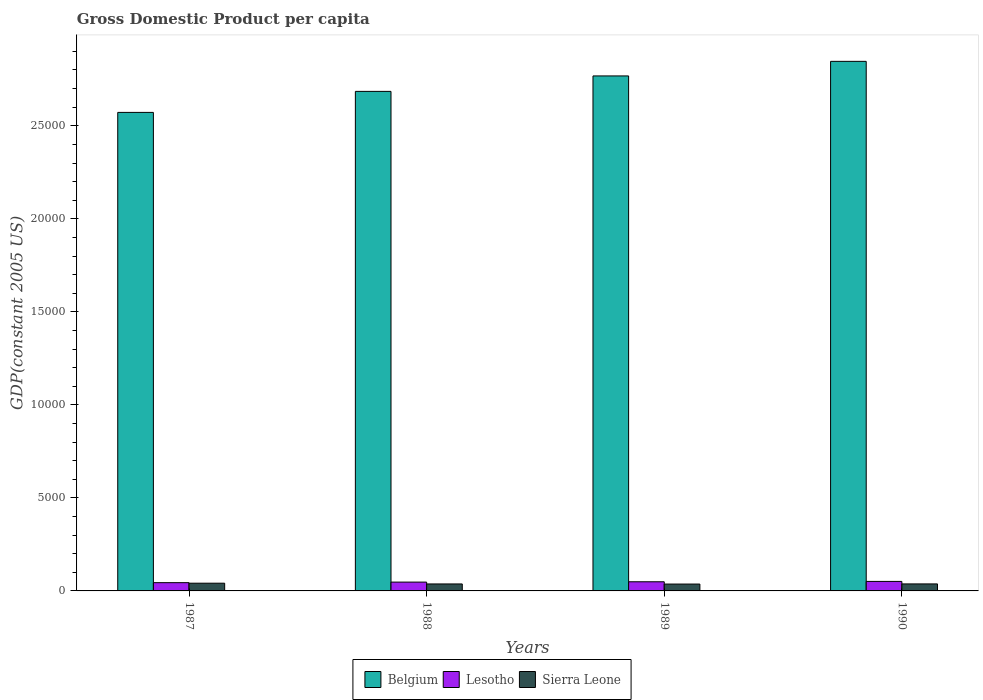How many groups of bars are there?
Offer a very short reply. 4. Are the number of bars per tick equal to the number of legend labels?
Your response must be concise. Yes. How many bars are there on the 3rd tick from the right?
Keep it short and to the point. 3. What is the GDP per capita in Belgium in 1989?
Ensure brevity in your answer.  2.77e+04. Across all years, what is the maximum GDP per capita in Sierra Leone?
Provide a succinct answer. 415.48. Across all years, what is the minimum GDP per capita in Belgium?
Offer a terse response. 2.57e+04. In which year was the GDP per capita in Lesotho maximum?
Keep it short and to the point. 1990. What is the total GDP per capita in Belgium in the graph?
Give a very brief answer. 1.09e+05. What is the difference between the GDP per capita in Lesotho in 1988 and that in 1989?
Your response must be concise. -17.88. What is the difference between the GDP per capita in Sierra Leone in 1989 and the GDP per capita in Belgium in 1990?
Keep it short and to the point. -2.81e+04. What is the average GDP per capita in Sierra Leone per year?
Keep it short and to the point. 384.01. In the year 1990, what is the difference between the GDP per capita in Sierra Leone and GDP per capita in Lesotho?
Keep it short and to the point. -134.24. In how many years, is the GDP per capita in Belgium greater than 4000 US$?
Provide a succinct answer. 4. What is the ratio of the GDP per capita in Lesotho in 1988 to that in 1989?
Provide a short and direct response. 0.96. Is the difference between the GDP per capita in Sierra Leone in 1987 and 1989 greater than the difference between the GDP per capita in Lesotho in 1987 and 1989?
Provide a short and direct response. Yes. What is the difference between the highest and the second highest GDP per capita in Sierra Leone?
Keep it short and to the point. 39.05. What is the difference between the highest and the lowest GDP per capita in Sierra Leone?
Your answer should be compact. 46.28. In how many years, is the GDP per capita in Lesotho greater than the average GDP per capita in Lesotho taken over all years?
Your answer should be very brief. 2. Is the sum of the GDP per capita in Belgium in 1988 and 1990 greater than the maximum GDP per capita in Lesotho across all years?
Ensure brevity in your answer.  Yes. What does the 3rd bar from the left in 1988 represents?
Your answer should be compact. Sierra Leone. What does the 1st bar from the right in 1989 represents?
Your response must be concise. Sierra Leone. Is it the case that in every year, the sum of the GDP per capita in Sierra Leone and GDP per capita in Lesotho is greater than the GDP per capita in Belgium?
Provide a succinct answer. No. Are all the bars in the graph horizontal?
Provide a succinct answer. No. Where does the legend appear in the graph?
Ensure brevity in your answer.  Bottom center. How many legend labels are there?
Offer a terse response. 3. How are the legend labels stacked?
Keep it short and to the point. Horizontal. What is the title of the graph?
Your answer should be compact. Gross Domestic Product per capita. Does "New Caledonia" appear as one of the legend labels in the graph?
Ensure brevity in your answer.  No. What is the label or title of the X-axis?
Your response must be concise. Years. What is the label or title of the Y-axis?
Your response must be concise. GDP(constant 2005 US). What is the GDP(constant 2005 US) of Belgium in 1987?
Keep it short and to the point. 2.57e+04. What is the GDP(constant 2005 US) of Lesotho in 1987?
Offer a terse response. 443.63. What is the GDP(constant 2005 US) of Sierra Leone in 1987?
Give a very brief answer. 415.48. What is the GDP(constant 2005 US) of Belgium in 1988?
Make the answer very short. 2.69e+04. What is the GDP(constant 2005 US) of Lesotho in 1988?
Your answer should be compact. 474. What is the GDP(constant 2005 US) of Sierra Leone in 1988?
Ensure brevity in your answer.  374.95. What is the GDP(constant 2005 US) of Belgium in 1989?
Your answer should be very brief. 2.77e+04. What is the GDP(constant 2005 US) of Lesotho in 1989?
Offer a terse response. 491.88. What is the GDP(constant 2005 US) of Sierra Leone in 1989?
Give a very brief answer. 369.2. What is the GDP(constant 2005 US) in Belgium in 1990?
Make the answer very short. 2.85e+04. What is the GDP(constant 2005 US) of Lesotho in 1990?
Offer a terse response. 510.67. What is the GDP(constant 2005 US) in Sierra Leone in 1990?
Provide a short and direct response. 376.42. Across all years, what is the maximum GDP(constant 2005 US) of Belgium?
Give a very brief answer. 2.85e+04. Across all years, what is the maximum GDP(constant 2005 US) in Lesotho?
Give a very brief answer. 510.67. Across all years, what is the maximum GDP(constant 2005 US) in Sierra Leone?
Keep it short and to the point. 415.48. Across all years, what is the minimum GDP(constant 2005 US) of Belgium?
Provide a short and direct response. 2.57e+04. Across all years, what is the minimum GDP(constant 2005 US) of Lesotho?
Ensure brevity in your answer.  443.63. Across all years, what is the minimum GDP(constant 2005 US) in Sierra Leone?
Your answer should be compact. 369.2. What is the total GDP(constant 2005 US) of Belgium in the graph?
Your answer should be very brief. 1.09e+05. What is the total GDP(constant 2005 US) in Lesotho in the graph?
Your answer should be compact. 1920.18. What is the total GDP(constant 2005 US) of Sierra Leone in the graph?
Your answer should be compact. 1536.05. What is the difference between the GDP(constant 2005 US) of Belgium in 1987 and that in 1988?
Ensure brevity in your answer.  -1129.35. What is the difference between the GDP(constant 2005 US) of Lesotho in 1987 and that in 1988?
Ensure brevity in your answer.  -30.37. What is the difference between the GDP(constant 2005 US) in Sierra Leone in 1987 and that in 1988?
Ensure brevity in your answer.  40.53. What is the difference between the GDP(constant 2005 US) in Belgium in 1987 and that in 1989?
Ensure brevity in your answer.  -1960.1. What is the difference between the GDP(constant 2005 US) in Lesotho in 1987 and that in 1989?
Your answer should be compact. -48.26. What is the difference between the GDP(constant 2005 US) of Sierra Leone in 1987 and that in 1989?
Offer a terse response. 46.28. What is the difference between the GDP(constant 2005 US) of Belgium in 1987 and that in 1990?
Your response must be concise. -2743.54. What is the difference between the GDP(constant 2005 US) of Lesotho in 1987 and that in 1990?
Offer a terse response. -67.04. What is the difference between the GDP(constant 2005 US) of Sierra Leone in 1987 and that in 1990?
Your response must be concise. 39.05. What is the difference between the GDP(constant 2005 US) in Belgium in 1988 and that in 1989?
Your answer should be very brief. -830.75. What is the difference between the GDP(constant 2005 US) in Lesotho in 1988 and that in 1989?
Offer a terse response. -17.88. What is the difference between the GDP(constant 2005 US) in Sierra Leone in 1988 and that in 1989?
Your answer should be very brief. 5.75. What is the difference between the GDP(constant 2005 US) in Belgium in 1988 and that in 1990?
Keep it short and to the point. -1614.19. What is the difference between the GDP(constant 2005 US) of Lesotho in 1988 and that in 1990?
Make the answer very short. -36.67. What is the difference between the GDP(constant 2005 US) of Sierra Leone in 1988 and that in 1990?
Make the answer very short. -1.48. What is the difference between the GDP(constant 2005 US) of Belgium in 1989 and that in 1990?
Offer a terse response. -783.45. What is the difference between the GDP(constant 2005 US) in Lesotho in 1989 and that in 1990?
Keep it short and to the point. -18.79. What is the difference between the GDP(constant 2005 US) in Sierra Leone in 1989 and that in 1990?
Offer a terse response. -7.22. What is the difference between the GDP(constant 2005 US) in Belgium in 1987 and the GDP(constant 2005 US) in Lesotho in 1988?
Keep it short and to the point. 2.52e+04. What is the difference between the GDP(constant 2005 US) in Belgium in 1987 and the GDP(constant 2005 US) in Sierra Leone in 1988?
Offer a very short reply. 2.53e+04. What is the difference between the GDP(constant 2005 US) of Lesotho in 1987 and the GDP(constant 2005 US) of Sierra Leone in 1988?
Give a very brief answer. 68.68. What is the difference between the GDP(constant 2005 US) of Belgium in 1987 and the GDP(constant 2005 US) of Lesotho in 1989?
Offer a terse response. 2.52e+04. What is the difference between the GDP(constant 2005 US) in Belgium in 1987 and the GDP(constant 2005 US) in Sierra Leone in 1989?
Make the answer very short. 2.54e+04. What is the difference between the GDP(constant 2005 US) in Lesotho in 1987 and the GDP(constant 2005 US) in Sierra Leone in 1989?
Offer a terse response. 74.43. What is the difference between the GDP(constant 2005 US) in Belgium in 1987 and the GDP(constant 2005 US) in Lesotho in 1990?
Make the answer very short. 2.52e+04. What is the difference between the GDP(constant 2005 US) in Belgium in 1987 and the GDP(constant 2005 US) in Sierra Leone in 1990?
Offer a terse response. 2.53e+04. What is the difference between the GDP(constant 2005 US) of Lesotho in 1987 and the GDP(constant 2005 US) of Sierra Leone in 1990?
Make the answer very short. 67.2. What is the difference between the GDP(constant 2005 US) of Belgium in 1988 and the GDP(constant 2005 US) of Lesotho in 1989?
Your answer should be compact. 2.64e+04. What is the difference between the GDP(constant 2005 US) in Belgium in 1988 and the GDP(constant 2005 US) in Sierra Leone in 1989?
Offer a terse response. 2.65e+04. What is the difference between the GDP(constant 2005 US) in Lesotho in 1988 and the GDP(constant 2005 US) in Sierra Leone in 1989?
Ensure brevity in your answer.  104.8. What is the difference between the GDP(constant 2005 US) of Belgium in 1988 and the GDP(constant 2005 US) of Lesotho in 1990?
Your answer should be very brief. 2.63e+04. What is the difference between the GDP(constant 2005 US) of Belgium in 1988 and the GDP(constant 2005 US) of Sierra Leone in 1990?
Provide a succinct answer. 2.65e+04. What is the difference between the GDP(constant 2005 US) in Lesotho in 1988 and the GDP(constant 2005 US) in Sierra Leone in 1990?
Offer a terse response. 97.57. What is the difference between the GDP(constant 2005 US) in Belgium in 1989 and the GDP(constant 2005 US) in Lesotho in 1990?
Your answer should be compact. 2.72e+04. What is the difference between the GDP(constant 2005 US) of Belgium in 1989 and the GDP(constant 2005 US) of Sierra Leone in 1990?
Your response must be concise. 2.73e+04. What is the difference between the GDP(constant 2005 US) in Lesotho in 1989 and the GDP(constant 2005 US) in Sierra Leone in 1990?
Your answer should be compact. 115.46. What is the average GDP(constant 2005 US) of Belgium per year?
Provide a succinct answer. 2.72e+04. What is the average GDP(constant 2005 US) of Lesotho per year?
Offer a terse response. 480.04. What is the average GDP(constant 2005 US) in Sierra Leone per year?
Your response must be concise. 384.01. In the year 1987, what is the difference between the GDP(constant 2005 US) in Belgium and GDP(constant 2005 US) in Lesotho?
Your answer should be compact. 2.53e+04. In the year 1987, what is the difference between the GDP(constant 2005 US) in Belgium and GDP(constant 2005 US) in Sierra Leone?
Your response must be concise. 2.53e+04. In the year 1987, what is the difference between the GDP(constant 2005 US) of Lesotho and GDP(constant 2005 US) of Sierra Leone?
Your response must be concise. 28.15. In the year 1988, what is the difference between the GDP(constant 2005 US) of Belgium and GDP(constant 2005 US) of Lesotho?
Offer a very short reply. 2.64e+04. In the year 1988, what is the difference between the GDP(constant 2005 US) of Belgium and GDP(constant 2005 US) of Sierra Leone?
Provide a short and direct response. 2.65e+04. In the year 1988, what is the difference between the GDP(constant 2005 US) of Lesotho and GDP(constant 2005 US) of Sierra Leone?
Make the answer very short. 99.05. In the year 1989, what is the difference between the GDP(constant 2005 US) of Belgium and GDP(constant 2005 US) of Lesotho?
Ensure brevity in your answer.  2.72e+04. In the year 1989, what is the difference between the GDP(constant 2005 US) of Belgium and GDP(constant 2005 US) of Sierra Leone?
Make the answer very short. 2.73e+04. In the year 1989, what is the difference between the GDP(constant 2005 US) in Lesotho and GDP(constant 2005 US) in Sierra Leone?
Ensure brevity in your answer.  122.68. In the year 1990, what is the difference between the GDP(constant 2005 US) in Belgium and GDP(constant 2005 US) in Lesotho?
Keep it short and to the point. 2.80e+04. In the year 1990, what is the difference between the GDP(constant 2005 US) in Belgium and GDP(constant 2005 US) in Sierra Leone?
Your answer should be compact. 2.81e+04. In the year 1990, what is the difference between the GDP(constant 2005 US) in Lesotho and GDP(constant 2005 US) in Sierra Leone?
Offer a terse response. 134.24. What is the ratio of the GDP(constant 2005 US) in Belgium in 1987 to that in 1988?
Provide a succinct answer. 0.96. What is the ratio of the GDP(constant 2005 US) in Lesotho in 1987 to that in 1988?
Make the answer very short. 0.94. What is the ratio of the GDP(constant 2005 US) of Sierra Leone in 1987 to that in 1988?
Your answer should be very brief. 1.11. What is the ratio of the GDP(constant 2005 US) of Belgium in 1987 to that in 1989?
Make the answer very short. 0.93. What is the ratio of the GDP(constant 2005 US) of Lesotho in 1987 to that in 1989?
Your response must be concise. 0.9. What is the ratio of the GDP(constant 2005 US) in Sierra Leone in 1987 to that in 1989?
Offer a terse response. 1.13. What is the ratio of the GDP(constant 2005 US) of Belgium in 1987 to that in 1990?
Offer a very short reply. 0.9. What is the ratio of the GDP(constant 2005 US) in Lesotho in 1987 to that in 1990?
Provide a short and direct response. 0.87. What is the ratio of the GDP(constant 2005 US) in Sierra Leone in 1987 to that in 1990?
Provide a short and direct response. 1.1. What is the ratio of the GDP(constant 2005 US) in Belgium in 1988 to that in 1989?
Offer a very short reply. 0.97. What is the ratio of the GDP(constant 2005 US) of Lesotho in 1988 to that in 1989?
Your response must be concise. 0.96. What is the ratio of the GDP(constant 2005 US) of Sierra Leone in 1988 to that in 1989?
Give a very brief answer. 1.02. What is the ratio of the GDP(constant 2005 US) of Belgium in 1988 to that in 1990?
Offer a very short reply. 0.94. What is the ratio of the GDP(constant 2005 US) of Lesotho in 1988 to that in 1990?
Provide a short and direct response. 0.93. What is the ratio of the GDP(constant 2005 US) in Sierra Leone in 1988 to that in 1990?
Your answer should be very brief. 1. What is the ratio of the GDP(constant 2005 US) in Belgium in 1989 to that in 1990?
Ensure brevity in your answer.  0.97. What is the ratio of the GDP(constant 2005 US) of Lesotho in 1989 to that in 1990?
Provide a short and direct response. 0.96. What is the ratio of the GDP(constant 2005 US) of Sierra Leone in 1989 to that in 1990?
Offer a very short reply. 0.98. What is the difference between the highest and the second highest GDP(constant 2005 US) of Belgium?
Your answer should be compact. 783.45. What is the difference between the highest and the second highest GDP(constant 2005 US) in Lesotho?
Your answer should be compact. 18.79. What is the difference between the highest and the second highest GDP(constant 2005 US) of Sierra Leone?
Make the answer very short. 39.05. What is the difference between the highest and the lowest GDP(constant 2005 US) of Belgium?
Your answer should be very brief. 2743.54. What is the difference between the highest and the lowest GDP(constant 2005 US) in Lesotho?
Ensure brevity in your answer.  67.04. What is the difference between the highest and the lowest GDP(constant 2005 US) of Sierra Leone?
Offer a very short reply. 46.28. 